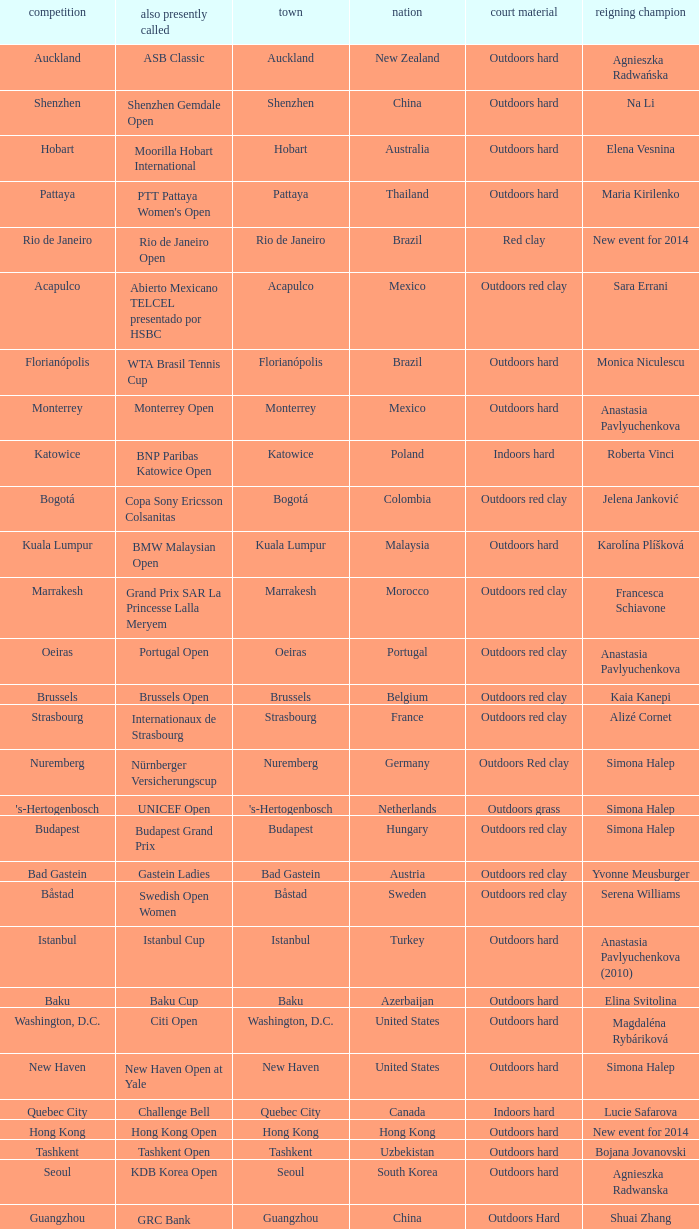Could you parse the entire table? {'header': ['competition', 'also presently called', 'town', 'nation', 'court material', 'reigning champion'], 'rows': [['Auckland', 'ASB Classic', 'Auckland', 'New Zealand', 'Outdoors hard', 'Agnieszka Radwańska'], ['Shenzhen', 'Shenzhen Gemdale Open', 'Shenzhen', 'China', 'Outdoors hard', 'Na Li'], ['Hobart', 'Moorilla Hobart International', 'Hobart', 'Australia', 'Outdoors hard', 'Elena Vesnina'], ['Pattaya', "PTT Pattaya Women's Open", 'Pattaya', 'Thailand', 'Outdoors hard', 'Maria Kirilenko'], ['Rio de Janeiro', 'Rio de Janeiro Open', 'Rio de Janeiro', 'Brazil', 'Red clay', 'New event for 2014'], ['Acapulco', 'Abierto Mexicano TELCEL presentado por HSBC', 'Acapulco', 'Mexico', 'Outdoors red clay', 'Sara Errani'], ['Florianópolis', 'WTA Brasil Tennis Cup', 'Florianópolis', 'Brazil', 'Outdoors hard', 'Monica Niculescu'], ['Monterrey', 'Monterrey Open', 'Monterrey', 'Mexico', 'Outdoors hard', 'Anastasia Pavlyuchenkova'], ['Katowice', 'BNP Paribas Katowice Open', 'Katowice', 'Poland', 'Indoors hard', 'Roberta Vinci'], ['Bogotá', 'Copa Sony Ericsson Colsanitas', 'Bogotá', 'Colombia', 'Outdoors red clay', 'Jelena Janković'], ['Kuala Lumpur', 'BMW Malaysian Open', 'Kuala Lumpur', 'Malaysia', 'Outdoors hard', 'Karolína Plíšková'], ['Marrakesh', 'Grand Prix SAR La Princesse Lalla Meryem', 'Marrakesh', 'Morocco', 'Outdoors red clay', 'Francesca Schiavone'], ['Oeiras', 'Portugal Open', 'Oeiras', 'Portugal', 'Outdoors red clay', 'Anastasia Pavlyuchenkova'], ['Brussels', 'Brussels Open', 'Brussels', 'Belgium', 'Outdoors red clay', 'Kaia Kanepi'], ['Strasbourg', 'Internationaux de Strasbourg', 'Strasbourg', 'France', 'Outdoors red clay', 'Alizé Cornet'], ['Nuremberg', 'Nürnberger Versicherungscup', 'Nuremberg', 'Germany', 'Outdoors Red clay', 'Simona Halep'], ["'s-Hertogenbosch", 'UNICEF Open', "'s-Hertogenbosch", 'Netherlands', 'Outdoors grass', 'Simona Halep'], ['Budapest', 'Budapest Grand Prix', 'Budapest', 'Hungary', 'Outdoors red clay', 'Simona Halep'], ['Bad Gastein', 'Gastein Ladies', 'Bad Gastein', 'Austria', 'Outdoors red clay', 'Yvonne Meusburger'], ['Båstad', 'Swedish Open Women', 'Båstad', 'Sweden', 'Outdoors red clay', 'Serena Williams'], ['Istanbul', 'Istanbul Cup', 'Istanbul', 'Turkey', 'Outdoors hard', 'Anastasia Pavlyuchenkova (2010)'], ['Baku', 'Baku Cup', 'Baku', 'Azerbaijan', 'Outdoors hard', 'Elina Svitolina'], ['Washington, D.C.', 'Citi Open', 'Washington, D.C.', 'United States', 'Outdoors hard', 'Magdaléna Rybáriková'], ['New Haven', 'New Haven Open at Yale', 'New Haven', 'United States', 'Outdoors hard', 'Simona Halep'], ['Quebec City', 'Challenge Bell', 'Quebec City', 'Canada', 'Indoors hard', 'Lucie Safarova'], ['Hong Kong', 'Hong Kong Open', 'Hong Kong', 'Hong Kong', 'Outdoors hard', 'New event for 2014'], ['Tashkent', 'Tashkent Open', 'Tashkent', 'Uzbekistan', 'Outdoors hard', 'Bojana Jovanovski'], ['Seoul', 'KDB Korea Open', 'Seoul', 'South Korea', 'Outdoors hard', 'Agnieszka Radwanska'], ['Guangzhou', "GRC Bank Guangzhou International Women's Open", 'Guangzhou', 'China', 'Outdoors Hard', 'Shuai Zhang'], ['Linz', 'Generali Ladies Linz', 'Linz', 'Austria', 'Indoors hard', 'Angelique Kerber'], ['Osaka', 'HP Open', 'Osaka', 'Japan', 'Outdoors hard', 'Samantha Stosur'], ['Luxembourg', 'BGL Luxembourg Open', 'Luxembourg City', 'Luxembourg', 'Indoors hard', 'Caroline Wozniacki']]} How many defending champs from thailand? 1.0. 